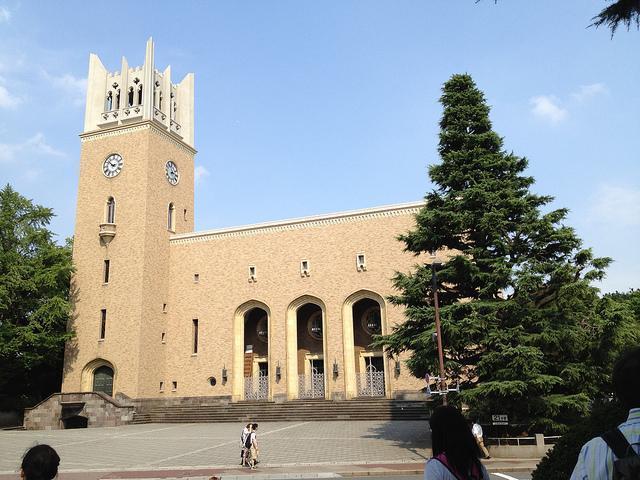How many clock faces are on the tower?
Give a very brief answer. 2. How many street poles?
Give a very brief answer. 1. How many people can you see?
Give a very brief answer. 2. How many bikes are there?
Give a very brief answer. 0. 